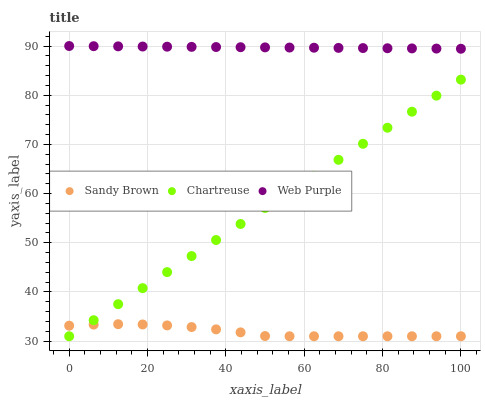Does Sandy Brown have the minimum area under the curve?
Answer yes or no. Yes. Does Web Purple have the maximum area under the curve?
Answer yes or no. Yes. Does Web Purple have the minimum area under the curve?
Answer yes or no. No. Does Sandy Brown have the maximum area under the curve?
Answer yes or no. No. Is Web Purple the smoothest?
Answer yes or no. Yes. Is Sandy Brown the roughest?
Answer yes or no. Yes. Is Sandy Brown the smoothest?
Answer yes or no. No. Is Web Purple the roughest?
Answer yes or no. No. Does Chartreuse have the lowest value?
Answer yes or no. Yes. Does Web Purple have the lowest value?
Answer yes or no. No. Does Web Purple have the highest value?
Answer yes or no. Yes. Does Sandy Brown have the highest value?
Answer yes or no. No. Is Chartreuse less than Web Purple?
Answer yes or no. Yes. Is Web Purple greater than Sandy Brown?
Answer yes or no. Yes. Does Sandy Brown intersect Chartreuse?
Answer yes or no. Yes. Is Sandy Brown less than Chartreuse?
Answer yes or no. No. Is Sandy Brown greater than Chartreuse?
Answer yes or no. No. Does Chartreuse intersect Web Purple?
Answer yes or no. No. 